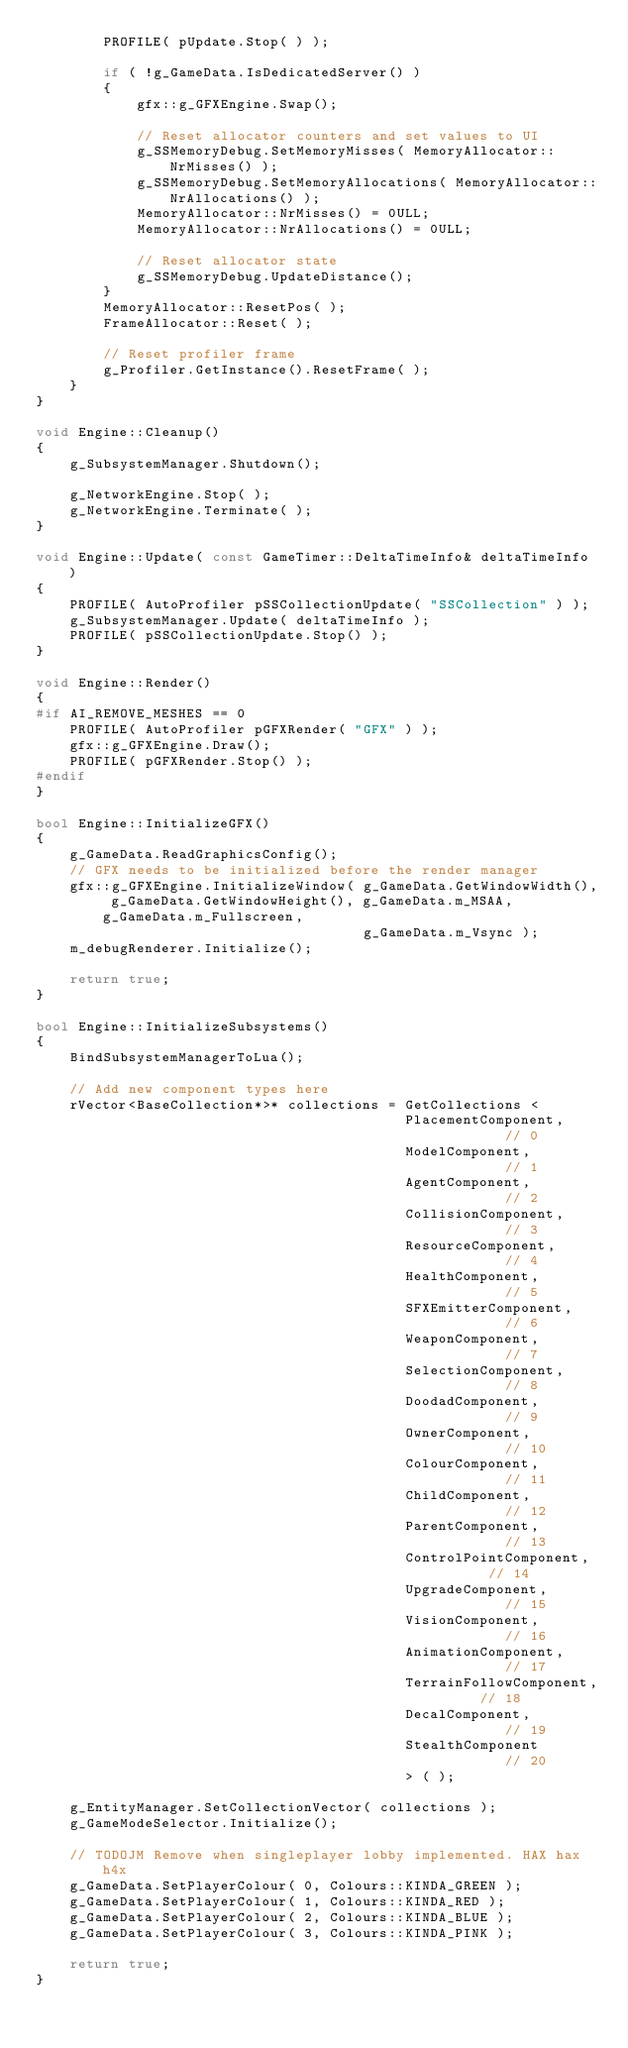<code> <loc_0><loc_0><loc_500><loc_500><_C++_>		PROFILE( pUpdate.Stop( ) );

		if ( !g_GameData.IsDedicatedServer() )
		{
			gfx::g_GFXEngine.Swap();

			// Reset allocator counters and set values to UI
			g_SSMemoryDebug.SetMemoryMisses( MemoryAllocator::NrMisses() );
			g_SSMemoryDebug.SetMemoryAllocations( MemoryAllocator::NrAllocations() );
			MemoryAllocator::NrMisses() = 0ULL;
			MemoryAllocator::NrAllocations() = 0ULL;

			// Reset allocator state
			g_SSMemoryDebug.UpdateDistance();
		}
		MemoryAllocator::ResetPos( );
		FrameAllocator::Reset( );

		// Reset profiler frame
		g_Profiler.GetInstance().ResetFrame( );
	}
}

void Engine::Cleanup()
{
	g_SubsystemManager.Shutdown();

	g_NetworkEngine.Stop( );
	g_NetworkEngine.Terminate( );
}

void Engine::Update( const GameTimer::DeltaTimeInfo& deltaTimeInfo )
{
	PROFILE( AutoProfiler pSSCollectionUpdate( "SSCollection" ) );
	g_SubsystemManager.Update( deltaTimeInfo );
	PROFILE( pSSCollectionUpdate.Stop() );
}

void Engine::Render()
{
#if AI_REMOVE_MESHES == 0
	PROFILE( AutoProfiler pGFXRender( "GFX" ) );
	gfx::g_GFXEngine.Draw();
	PROFILE( pGFXRender.Stop() );
#endif
}

bool Engine::InitializeGFX()
{
	g_GameData.ReadGraphicsConfig();
	// GFX needs to be initialized before the render manager
	gfx::g_GFXEngine.InitializeWindow( g_GameData.GetWindowWidth(), g_GameData.GetWindowHeight(), g_GameData.m_MSAA, g_GameData.m_Fullscreen,
									   g_GameData.m_Vsync );
	m_debugRenderer.Initialize();

	return true;
}

bool Engine::InitializeSubsystems()
{
	BindSubsystemManagerToLua();

	// Add new component types here
	rVector<BaseCollection*>* collections = GetCollections <
											PlacementComponent,			// 0
											ModelComponent,				// 1
											AgentComponent,				// 2
											CollisionComponent,			// 3
											ResourceComponent,			// 4
											HealthComponent,			// 5
											SFXEmitterComponent,		// 6
											WeaponComponent,			// 7
											SelectionComponent,			// 8
											DoodadComponent,			// 9
											OwnerComponent,				// 10
											ColourComponent,			// 11
											ChildComponent,				// 12
											ParentComponent,			// 13
											ControlPointComponent,		// 14
											UpgradeComponent,			// 15
											VisionComponent,			// 16
											AnimationComponent,			// 17
											TerrainFollowComponent,		// 18
											DecalComponent,				// 19
											StealthComponent			// 20
											> ( );

	g_EntityManager.SetCollectionVector( collections );
	g_GameModeSelector.Initialize();

	// TODOJM Remove when singleplayer lobby implemented. HAX hax h4x
	g_GameData.SetPlayerColour( 0, Colours::KINDA_GREEN );
	g_GameData.SetPlayerColour( 1, Colours::KINDA_RED );
	g_GameData.SetPlayerColour( 2, Colours::KINDA_BLUE );
	g_GameData.SetPlayerColour( 3, Colours::KINDA_PINK );

	return true;
}
</code> 